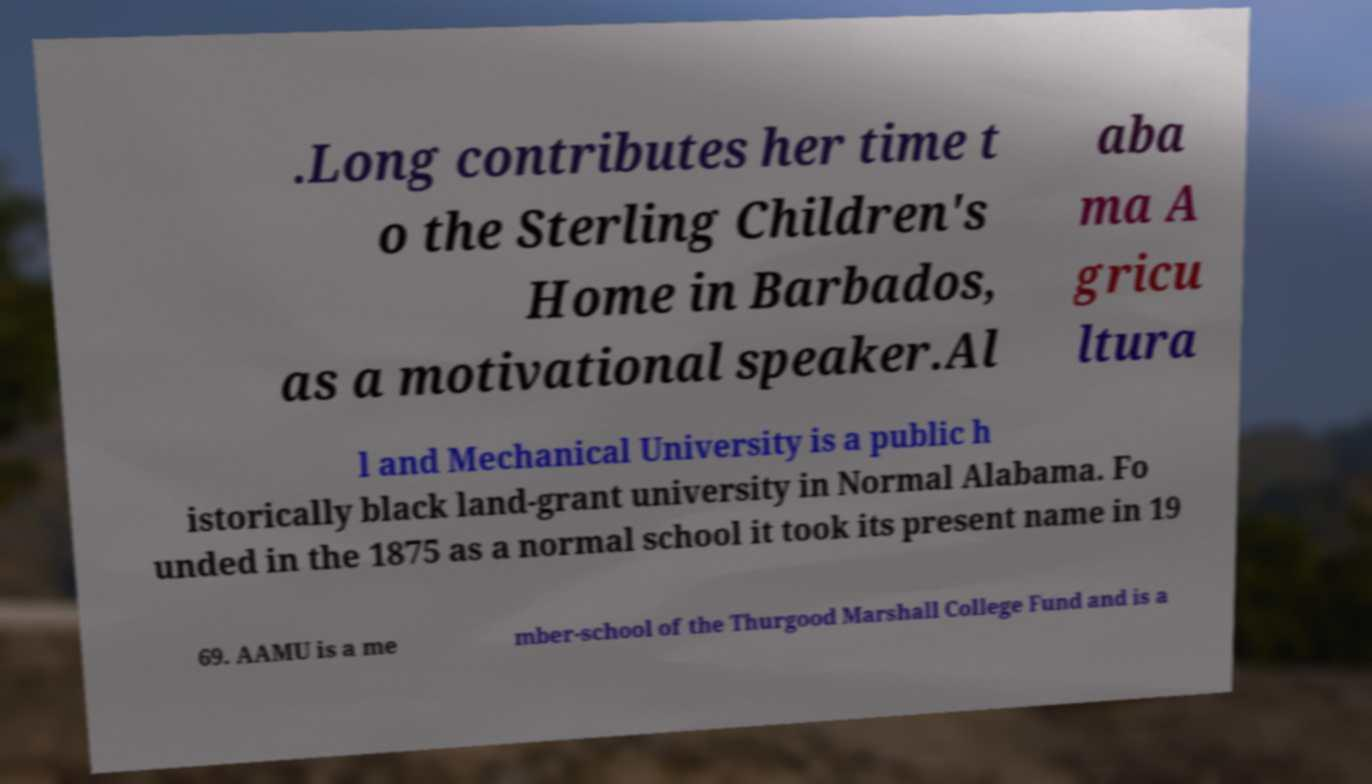Can you read and provide the text displayed in the image?This photo seems to have some interesting text. Can you extract and type it out for me? .Long contributes her time t o the Sterling Children's Home in Barbados, as a motivational speaker.Al aba ma A gricu ltura l and Mechanical University is a public h istorically black land-grant university in Normal Alabama. Fo unded in the 1875 as a normal school it took its present name in 19 69. AAMU is a me mber-school of the Thurgood Marshall College Fund and is a 